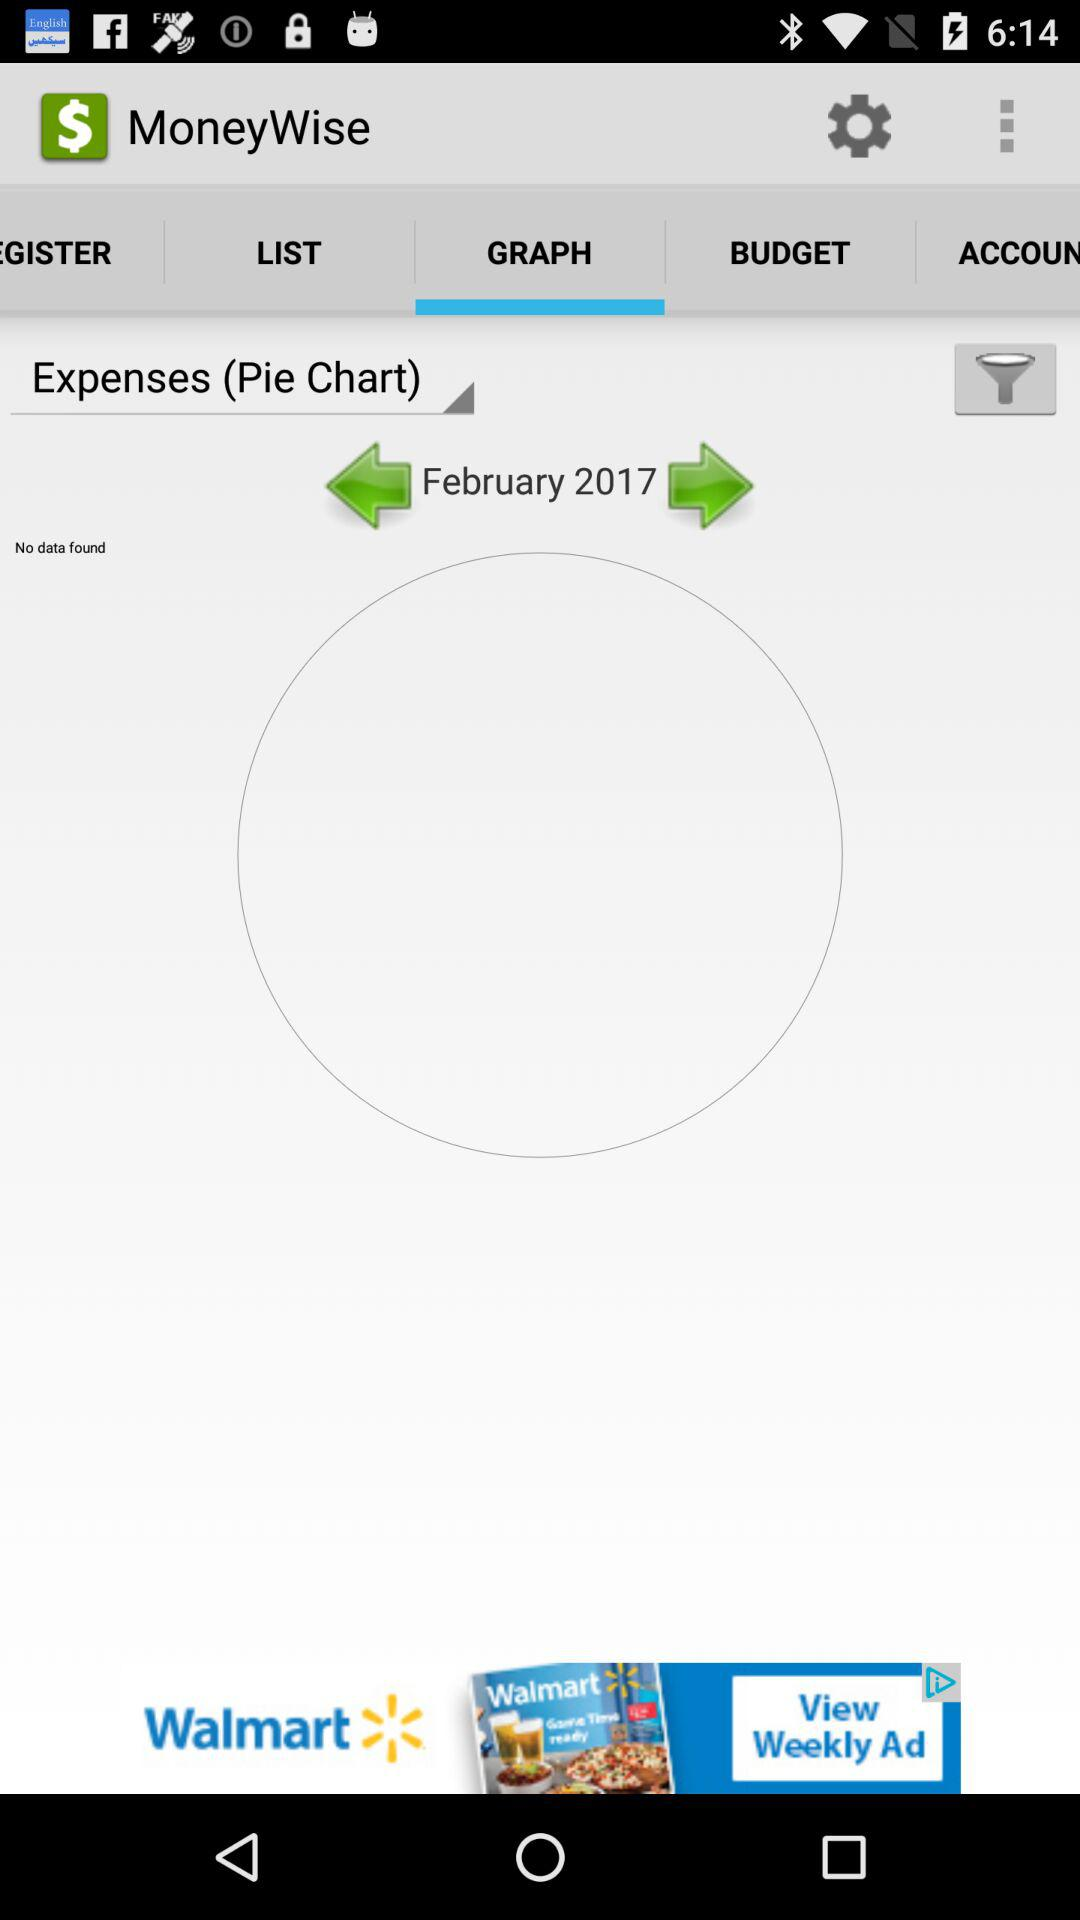What is the application name? The application name is "MoneyWise". 